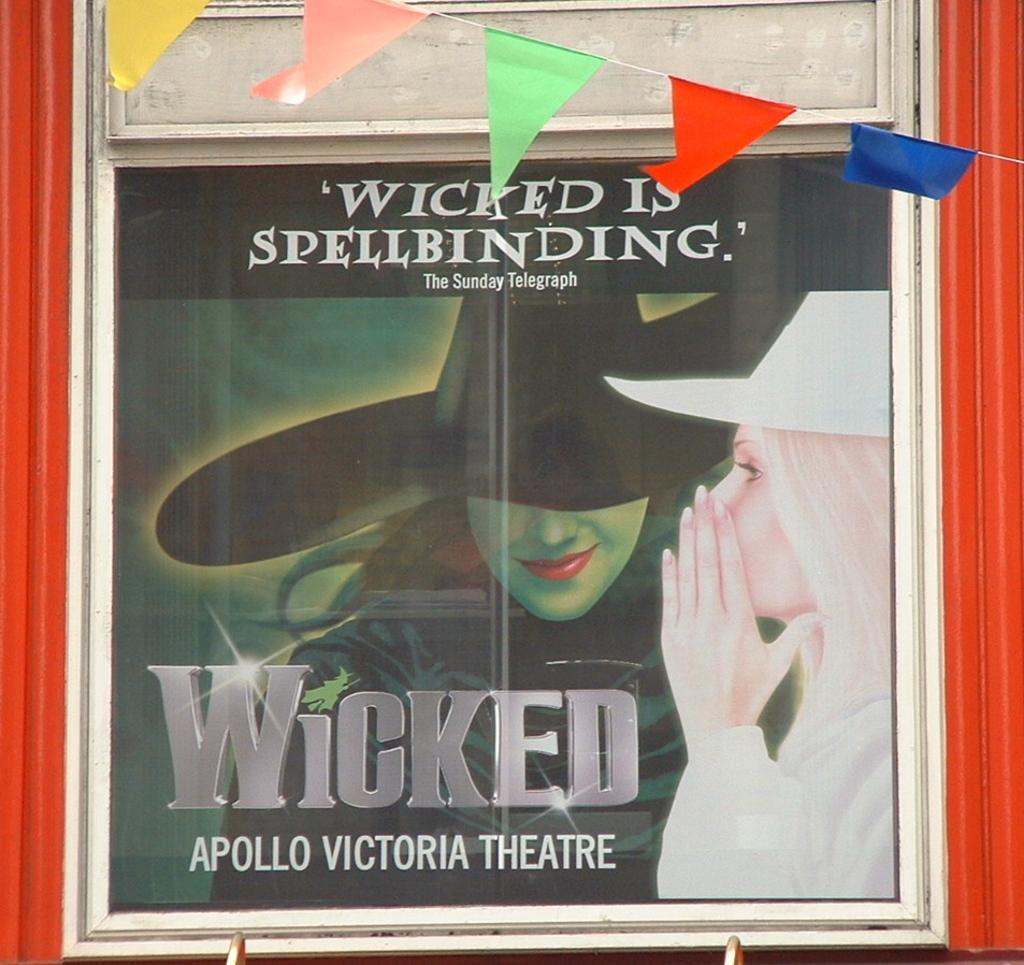What is the name of this show?
Provide a succinct answer. Wicked. Where is this show taking place?
Make the answer very short. Apollo victoria theatre. 